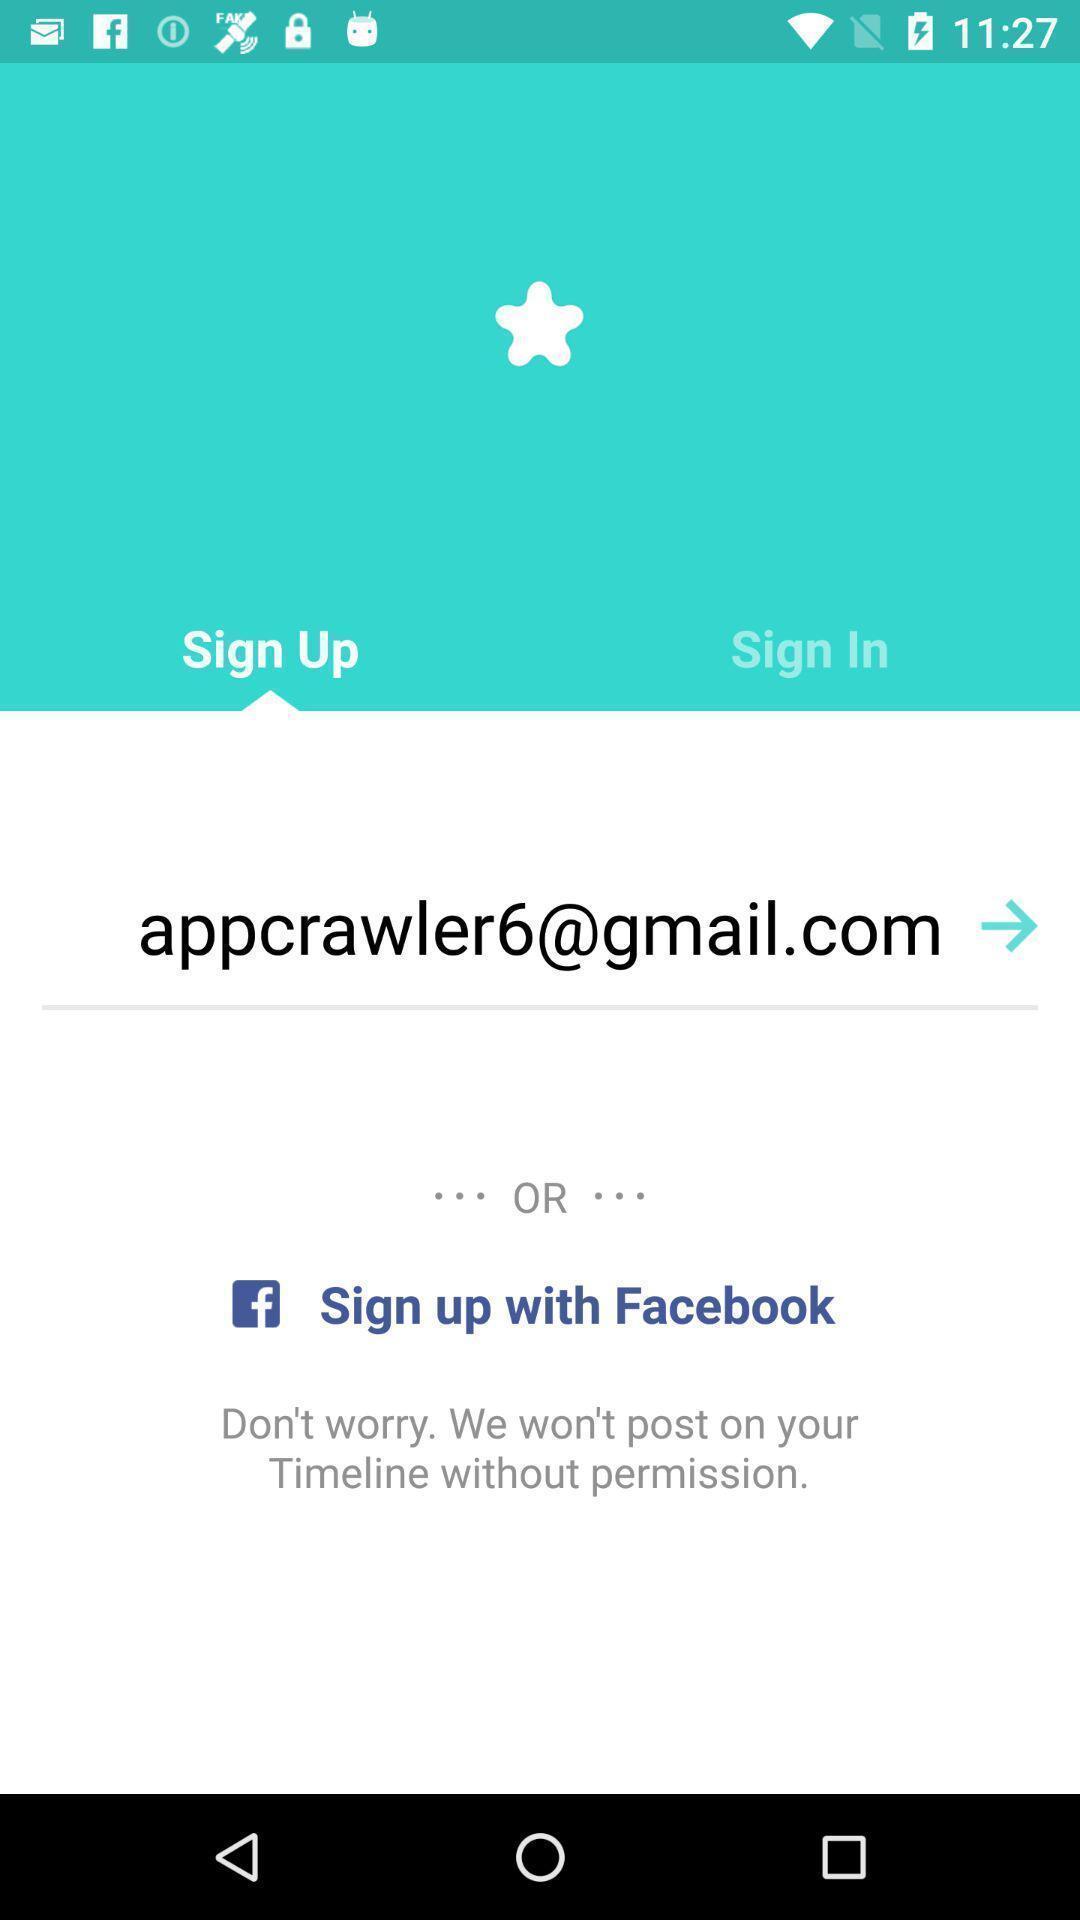Describe the key features of this screenshot. Welcome page displaying sign up. 